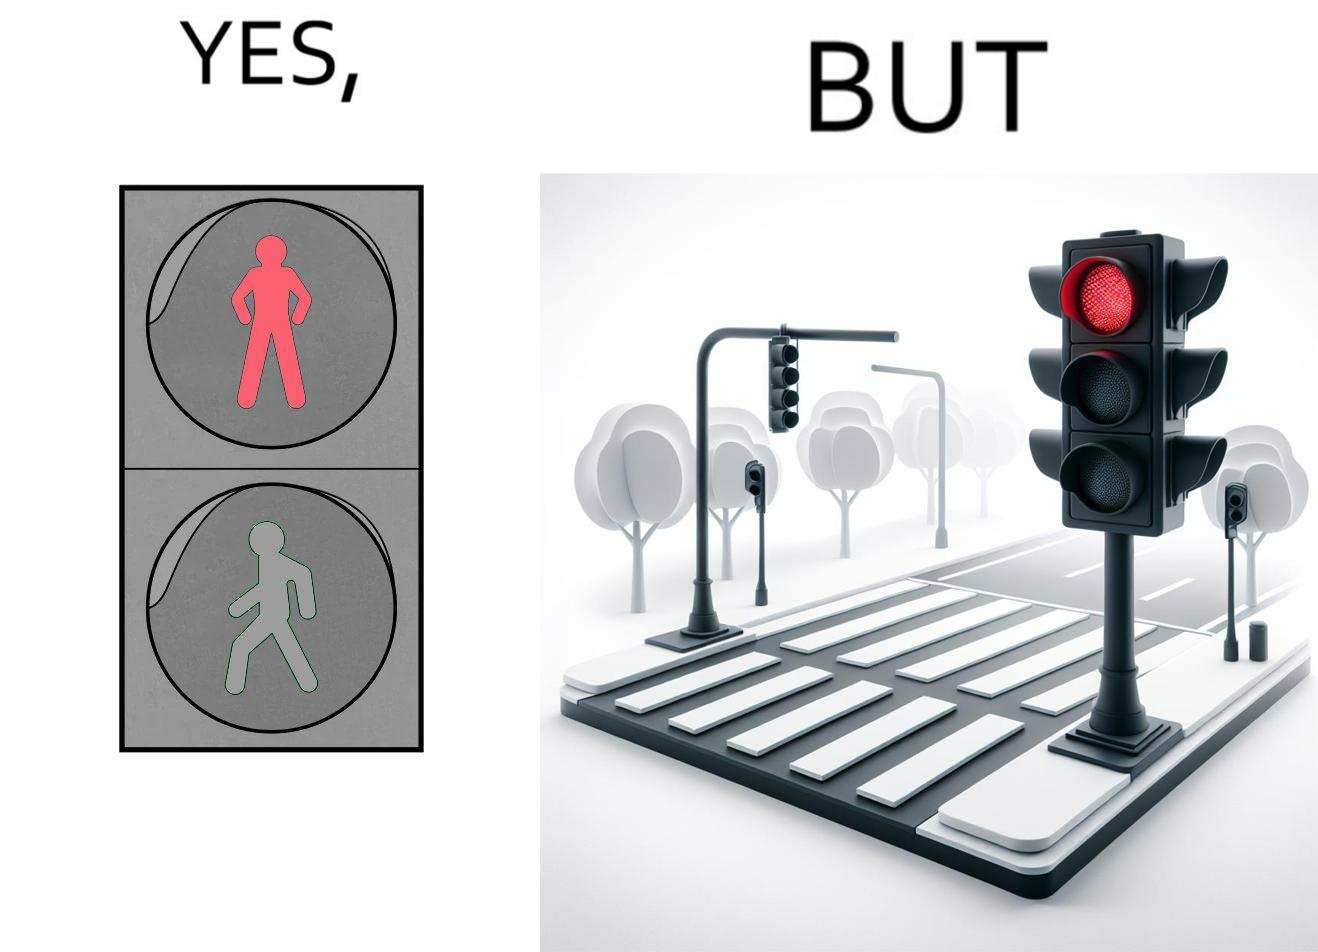Provide a description of this image. The image is funny, as the traffic light for pedestrains is red, even though it is at a zebra crossing, which does not need a red light for stopping a pedestrain from crossing. Also, there are no people or vehicles around, which makes the image even funnier. 